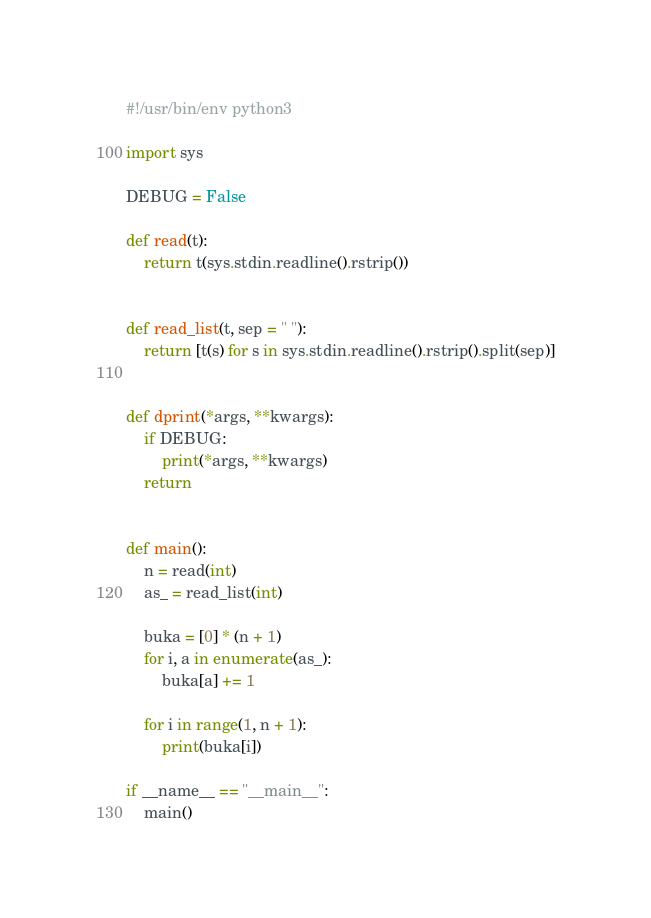<code> <loc_0><loc_0><loc_500><loc_500><_Python_>#!/usr/bin/env python3

import sys

DEBUG = False

def read(t):
    return t(sys.stdin.readline().rstrip())


def read_list(t, sep = " "):
    return [t(s) for s in sys.stdin.readline().rstrip().split(sep)]


def dprint(*args, **kwargs):
    if DEBUG:
        print(*args, **kwargs)
    return


def main():
    n = read(int)
    as_ = read_list(int)

    buka = [0] * (n + 1)
    for i, a in enumerate(as_):
        buka[a] += 1

    for i in range(1, n + 1):
        print(buka[i])

if __name__ == "__main__":
    main()
</code> 